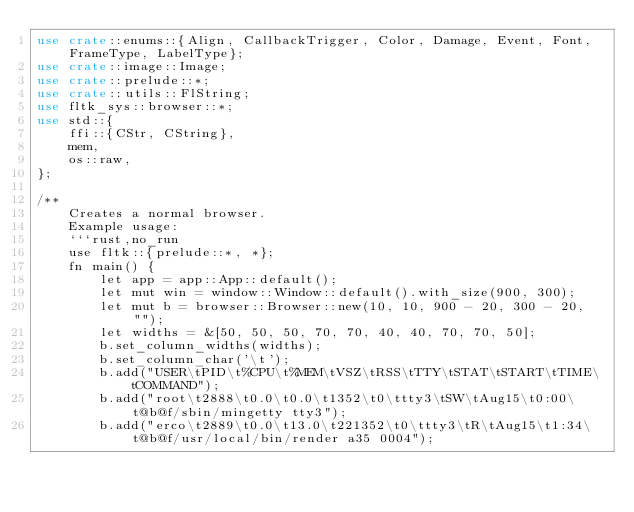<code> <loc_0><loc_0><loc_500><loc_500><_Rust_>use crate::enums::{Align, CallbackTrigger, Color, Damage, Event, Font, FrameType, LabelType};
use crate::image::Image;
use crate::prelude::*;
use crate::utils::FlString;
use fltk_sys::browser::*;
use std::{
    ffi::{CStr, CString},
    mem,
    os::raw,
};

/**
    Creates a normal browser.
    Example usage:
    ```rust,no_run
    use fltk::{prelude::*, *};
    fn main() {
        let app = app::App::default();
        let mut win = window::Window::default().with_size(900, 300);
        let mut b = browser::Browser::new(10, 10, 900 - 20, 300 - 20, "");
        let widths = &[50, 50, 50, 70, 70, 40, 40, 70, 70, 50];
        b.set_column_widths(widths);
        b.set_column_char('\t');
        b.add("USER\tPID\t%CPU\t%MEM\tVSZ\tRSS\tTTY\tSTAT\tSTART\tTIME\tCOMMAND");
        b.add("root\t2888\t0.0\t0.0\t1352\t0\ttty3\tSW\tAug15\t0:00\t@b@f/sbin/mingetty tty3");
        b.add("erco\t2889\t0.0\t13.0\t221352\t0\ttty3\tR\tAug15\t1:34\t@b@f/usr/local/bin/render a35 0004");</code> 